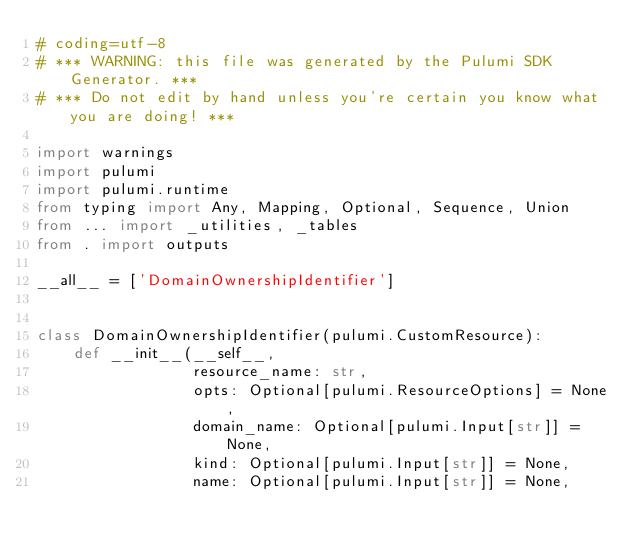<code> <loc_0><loc_0><loc_500><loc_500><_Python_># coding=utf-8
# *** WARNING: this file was generated by the Pulumi SDK Generator. ***
# *** Do not edit by hand unless you're certain you know what you are doing! ***

import warnings
import pulumi
import pulumi.runtime
from typing import Any, Mapping, Optional, Sequence, Union
from ... import _utilities, _tables
from . import outputs

__all__ = ['DomainOwnershipIdentifier']


class DomainOwnershipIdentifier(pulumi.CustomResource):
    def __init__(__self__,
                 resource_name: str,
                 opts: Optional[pulumi.ResourceOptions] = None,
                 domain_name: Optional[pulumi.Input[str]] = None,
                 kind: Optional[pulumi.Input[str]] = None,
                 name: Optional[pulumi.Input[str]] = None,</code> 